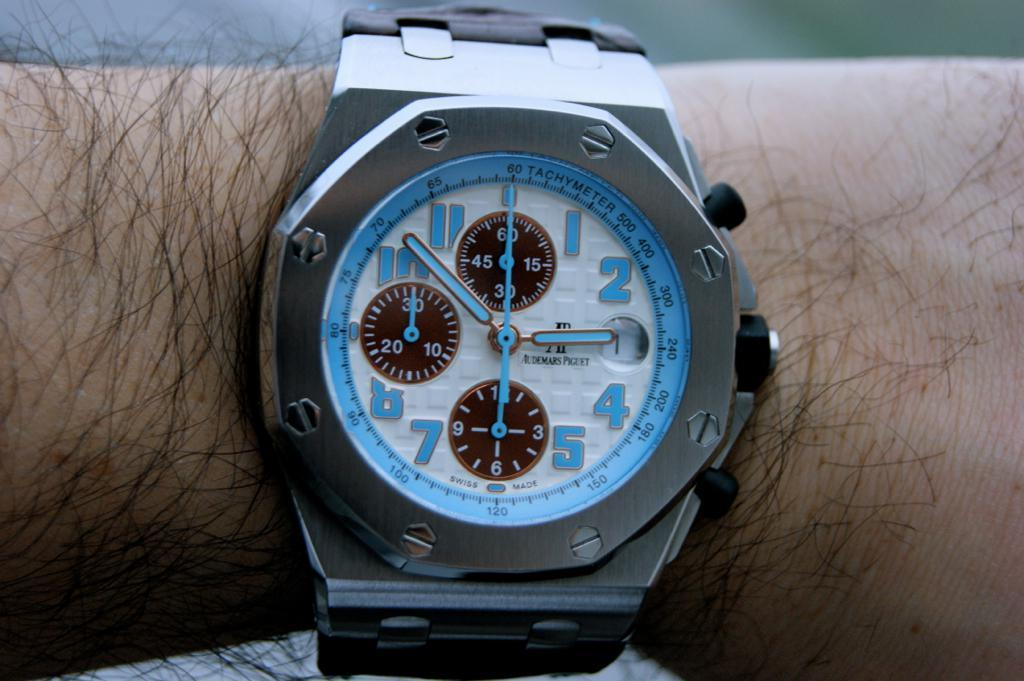<image>
Provide a brief description of the given image. A Demars Piguet watch worn on a man's wrist has blue hands. 